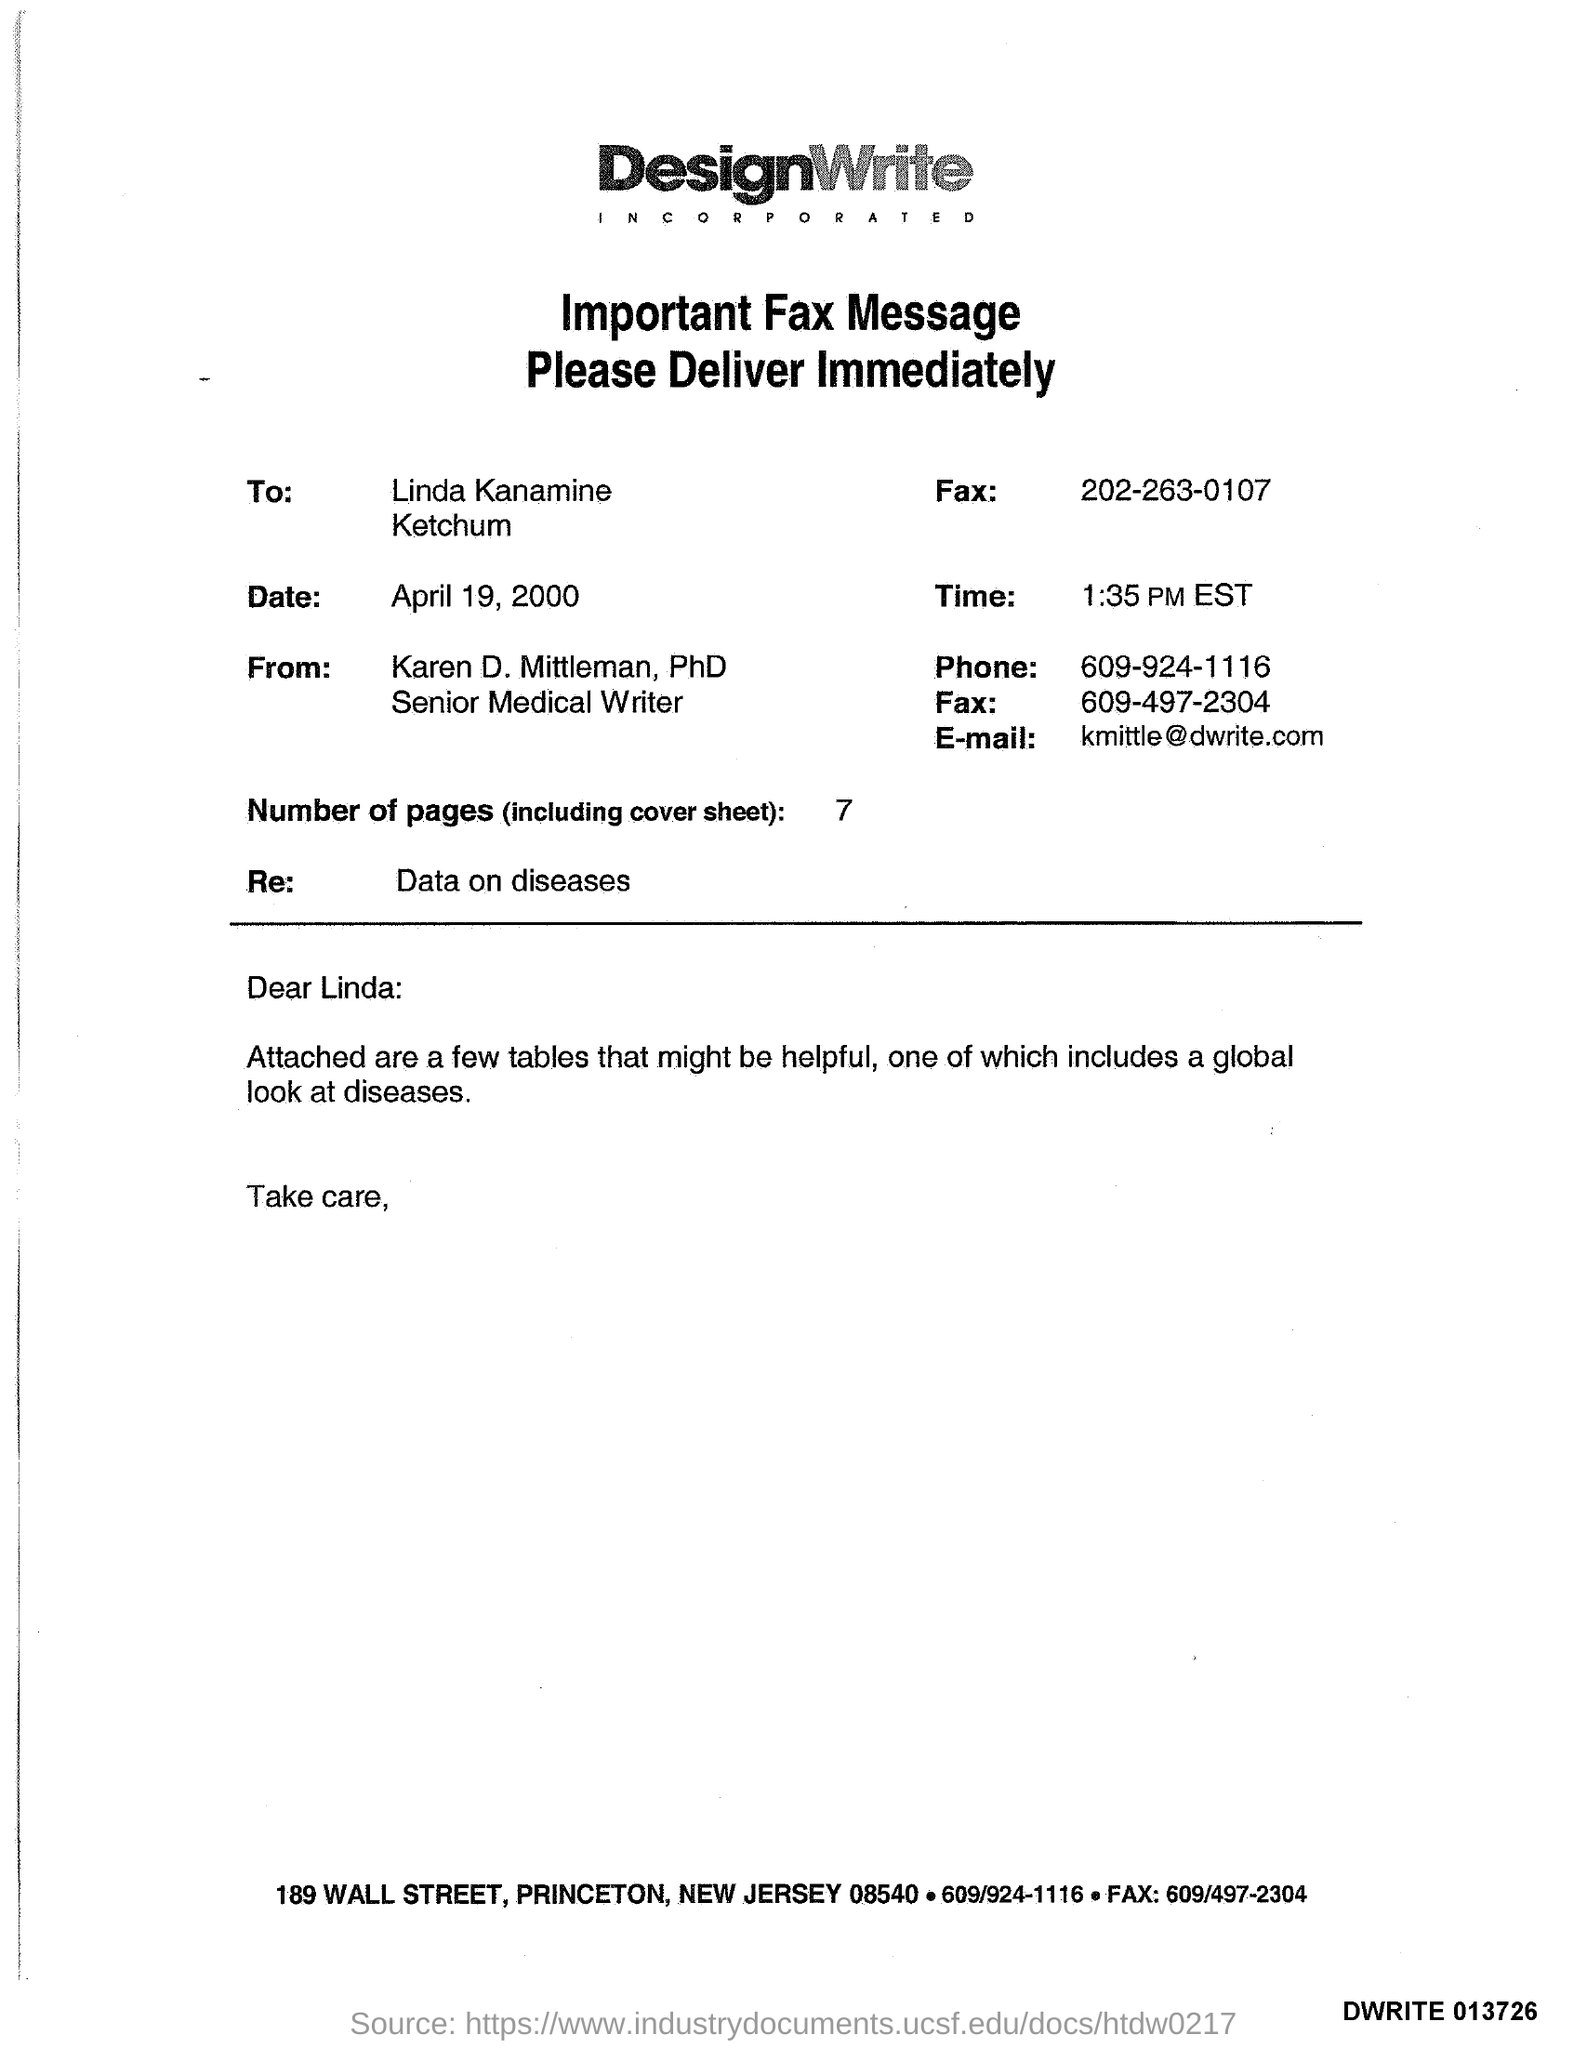Who is the Memorandum addressed to ?
Give a very brief answer. Linda Kanamine Ketchum. What is the Receiver Fax Number ?
Make the answer very short. 202-263-0107. How many Pages are in the sheet ?
Your answer should be compact. 7. What is the Sender Fax Number ?
Your response must be concise. 609-497-2304. What is the date mentioned in the document ?
Provide a succinct answer. April 19, 2000. What is the Sender Phone Number ?
Your answer should be very brief. 609-924-1116. What is written in the Letter Head ?
Provide a short and direct response. DesignWrite. 